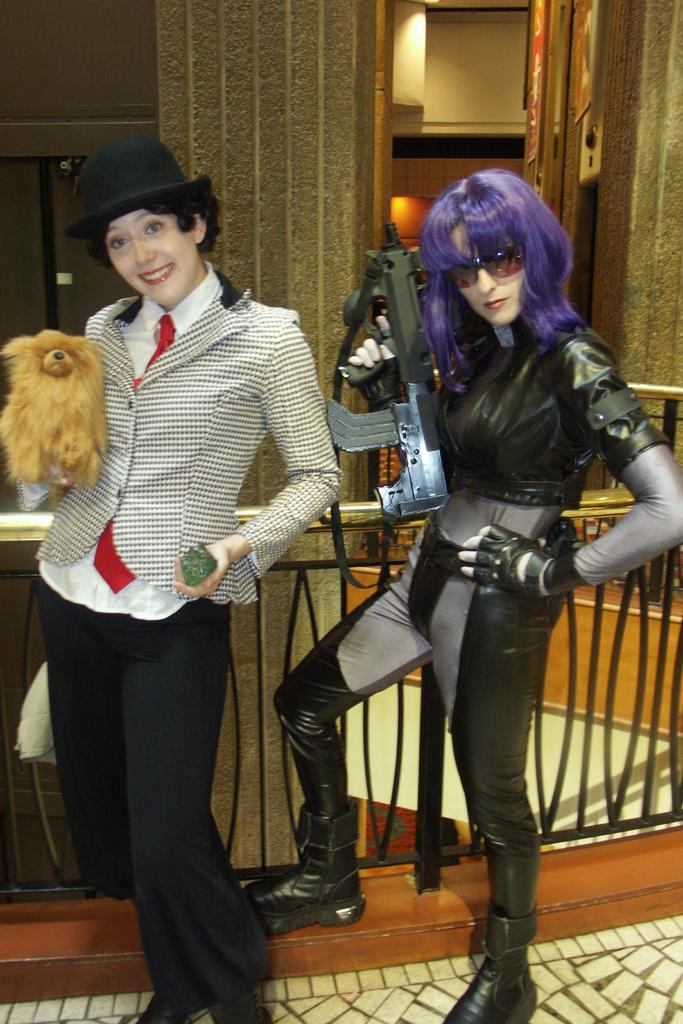What can be seen in the image? There are women standing in the image. What are the women wearing? The women are wearing stage costumes. What can be seen in the background of the image? There are poles, a grill, and an electric light in the background of the image. What type of wool is being used to create the acoustics in the image? There is no wool or mention of acoustics in the image; it features women wearing stage costumes and a background with poles, a grill, and an electric light. 